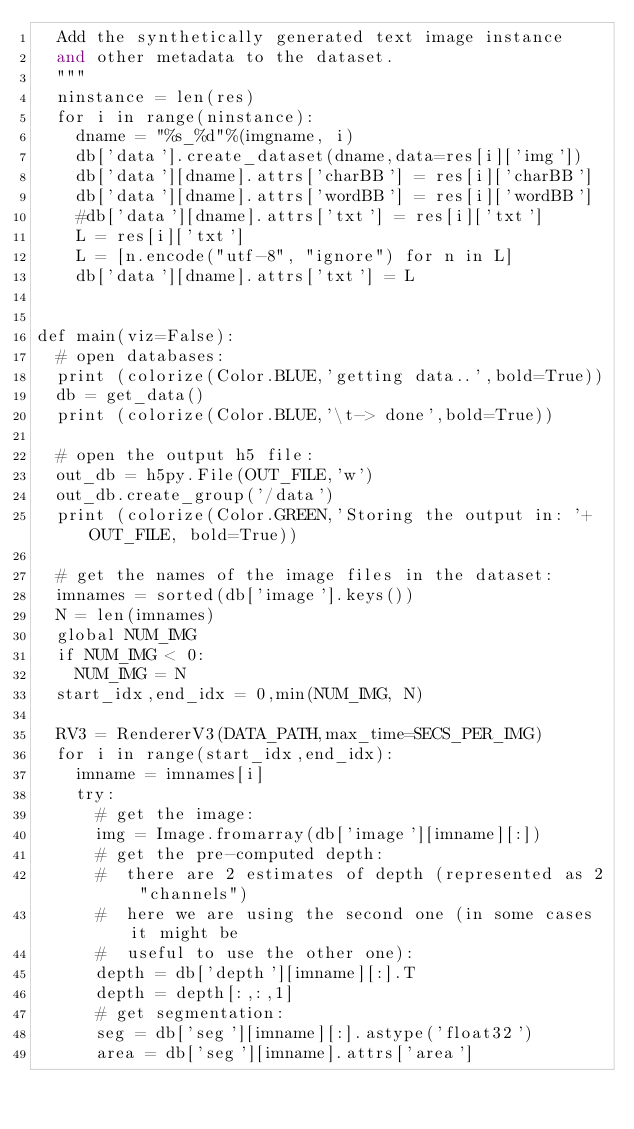<code> <loc_0><loc_0><loc_500><loc_500><_Python_>  Add the synthetically generated text image instance
  and other metadata to the dataset.
  """
  ninstance = len(res)
  for i in range(ninstance):
    dname = "%s_%d"%(imgname, i)
    db['data'].create_dataset(dname,data=res[i]['img'])
    db['data'][dname].attrs['charBB'] = res[i]['charBB']
    db['data'][dname].attrs['wordBB'] = res[i]['wordBB']        
    #db['data'][dname].attrs['txt'] = res[i]['txt']
    L = res[i]['txt']
    L = [n.encode("utf-8", "ignore") for n in L]
    db['data'][dname].attrs['txt'] = L


def main(viz=False):
  # open databases:
  print (colorize(Color.BLUE,'getting data..',bold=True))
  db = get_data()
  print (colorize(Color.BLUE,'\t-> done',bold=True))

  # open the output h5 file:
  out_db = h5py.File(OUT_FILE,'w')
  out_db.create_group('/data')
  print (colorize(Color.GREEN,'Storing the output in: '+OUT_FILE, bold=True))

  # get the names of the image files in the dataset:
  imnames = sorted(db['image'].keys())
  N = len(imnames)
  global NUM_IMG
  if NUM_IMG < 0:
    NUM_IMG = N
  start_idx,end_idx = 0,min(NUM_IMG, N)

  RV3 = RendererV3(DATA_PATH,max_time=SECS_PER_IMG)
  for i in range(start_idx,end_idx):
    imname = imnames[i]
    try:
      # get the image:
      img = Image.fromarray(db['image'][imname][:])
      # get the pre-computed depth:
      #  there are 2 estimates of depth (represented as 2 "channels")
      #  here we are using the second one (in some cases it might be
      #  useful to use the other one):
      depth = db['depth'][imname][:].T
      depth = depth[:,:,1]
      # get segmentation:
      seg = db['seg'][imname][:].astype('float32')
      area = db['seg'][imname].attrs['area']</code> 